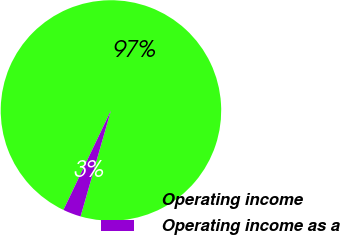Convert chart to OTSL. <chart><loc_0><loc_0><loc_500><loc_500><pie_chart><fcel>Operating income<fcel>Operating income as a<nl><fcel>97.35%<fcel>2.65%<nl></chart> 